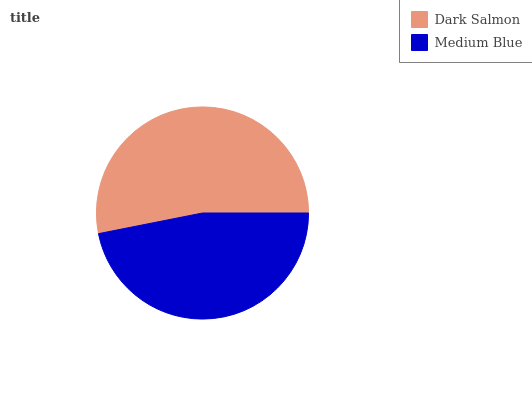Is Medium Blue the minimum?
Answer yes or no. Yes. Is Dark Salmon the maximum?
Answer yes or no. Yes. Is Medium Blue the maximum?
Answer yes or no. No. Is Dark Salmon greater than Medium Blue?
Answer yes or no. Yes. Is Medium Blue less than Dark Salmon?
Answer yes or no. Yes. Is Medium Blue greater than Dark Salmon?
Answer yes or no. No. Is Dark Salmon less than Medium Blue?
Answer yes or no. No. Is Dark Salmon the high median?
Answer yes or no. Yes. Is Medium Blue the low median?
Answer yes or no. Yes. Is Medium Blue the high median?
Answer yes or no. No. Is Dark Salmon the low median?
Answer yes or no. No. 